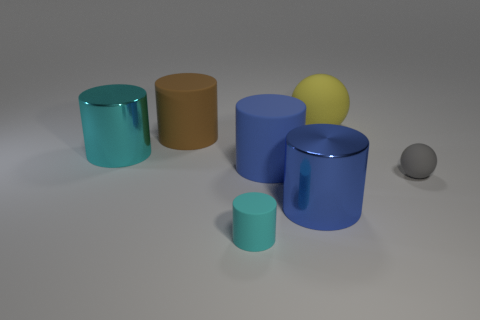The shiny object left of the cylinder on the right side of the blue matte cylinder is what color? cyan 